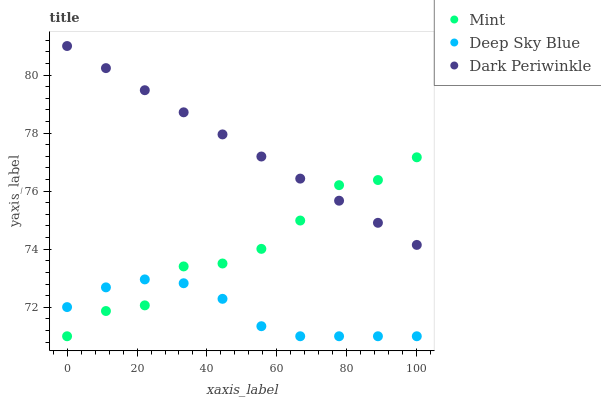Does Deep Sky Blue have the minimum area under the curve?
Answer yes or no. Yes. Does Dark Periwinkle have the maximum area under the curve?
Answer yes or no. Yes. Does Dark Periwinkle have the minimum area under the curve?
Answer yes or no. No. Does Deep Sky Blue have the maximum area under the curve?
Answer yes or no. No. Is Dark Periwinkle the smoothest?
Answer yes or no. Yes. Is Mint the roughest?
Answer yes or no. Yes. Is Deep Sky Blue the smoothest?
Answer yes or no. No. Is Deep Sky Blue the roughest?
Answer yes or no. No. Does Mint have the lowest value?
Answer yes or no. Yes. Does Dark Periwinkle have the lowest value?
Answer yes or no. No. Does Dark Periwinkle have the highest value?
Answer yes or no. Yes. Does Deep Sky Blue have the highest value?
Answer yes or no. No. Is Deep Sky Blue less than Dark Periwinkle?
Answer yes or no. Yes. Is Dark Periwinkle greater than Deep Sky Blue?
Answer yes or no. Yes. Does Dark Periwinkle intersect Mint?
Answer yes or no. Yes. Is Dark Periwinkle less than Mint?
Answer yes or no. No. Is Dark Periwinkle greater than Mint?
Answer yes or no. No. Does Deep Sky Blue intersect Dark Periwinkle?
Answer yes or no. No. 